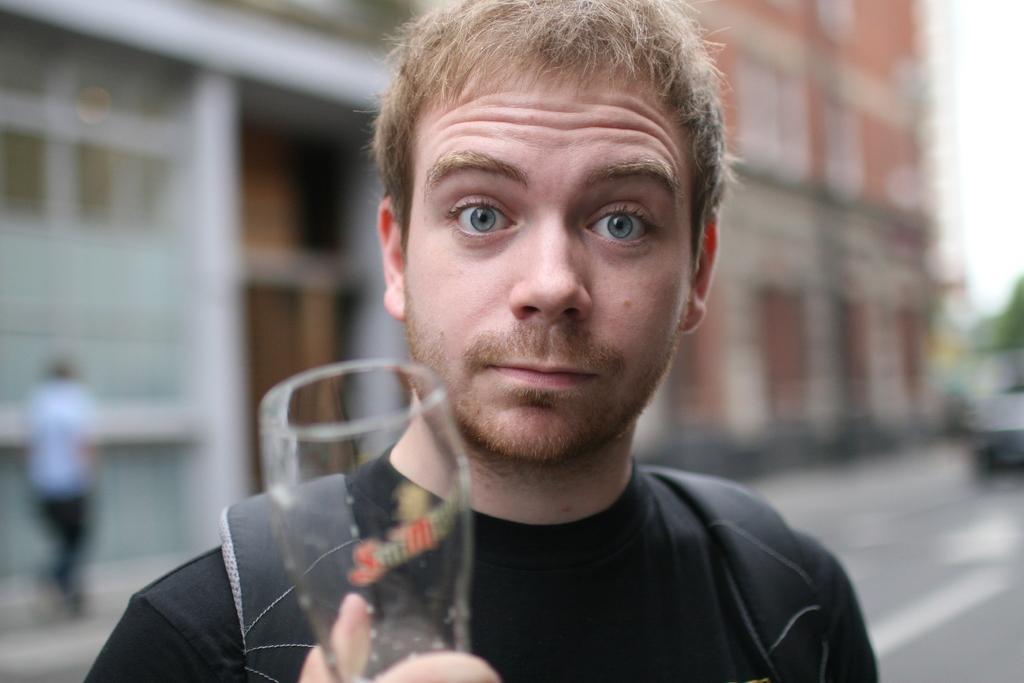Can you describe this image briefly? In this image, we can see a person is holding a glass and watching. Background we can see blur view. Here we can see wall, human and road. 